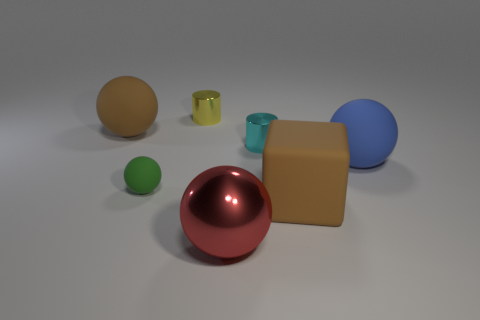Add 2 big purple rubber cylinders. How many objects exist? 9 Subtract all cubes. How many objects are left? 6 Subtract all gray cylinders. Subtract all large brown matte cubes. How many objects are left? 6 Add 2 tiny yellow cylinders. How many tiny yellow cylinders are left? 3 Add 3 small green rubber balls. How many small green rubber balls exist? 4 Subtract 0 gray cylinders. How many objects are left? 7 